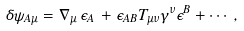Convert formula to latex. <formula><loc_0><loc_0><loc_500><loc_500>\delta \psi _ { A \mu } = { \nabla } _ { \mu } \, \epsilon _ { A } \, + \epsilon _ { A B } T _ { \mu \nu } \gamma ^ { \nu } \epsilon ^ { B } + \cdots \, ,</formula> 